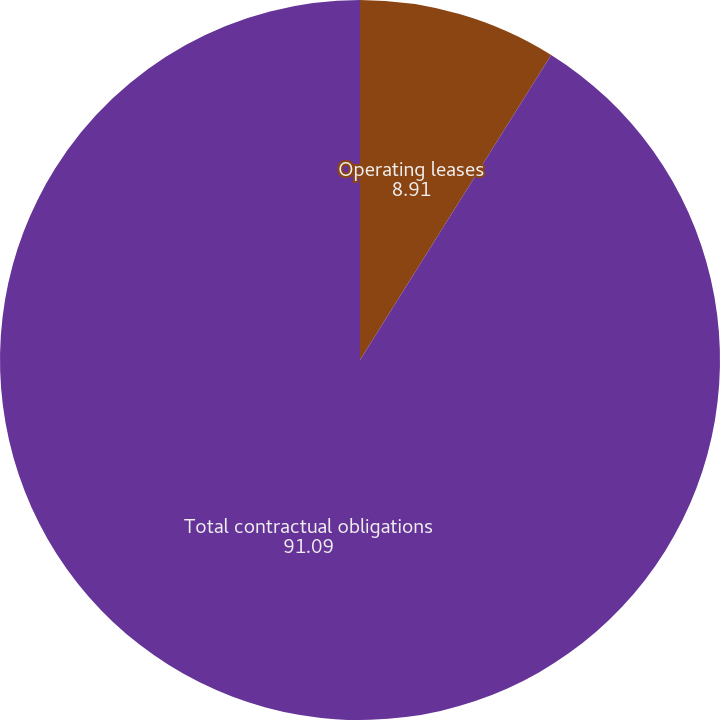Convert chart to OTSL. <chart><loc_0><loc_0><loc_500><loc_500><pie_chart><fcel>Operating leases<fcel>Total contractual obligations<nl><fcel>8.91%<fcel>91.09%<nl></chart> 